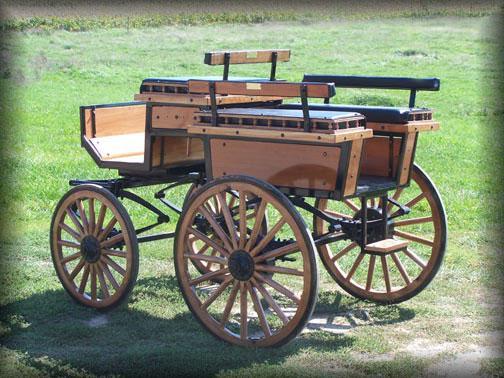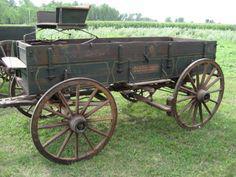The first image is the image on the left, the second image is the image on the right. Analyze the images presented: Is the assertion "The front leads of the carriage are resting on the ground in one of the images." valid? Answer yes or no. No. The first image is the image on the left, the second image is the image on the right. For the images shown, is this caption "An image features a four-wheeled cart with distinctly smaller wheels at the front." true? Answer yes or no. Yes. 